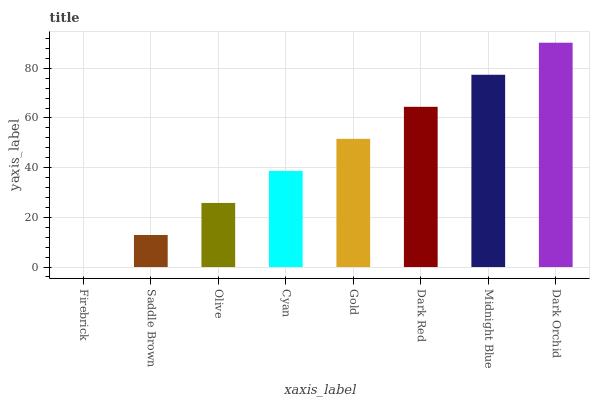Is Firebrick the minimum?
Answer yes or no. Yes. Is Dark Orchid the maximum?
Answer yes or no. Yes. Is Saddle Brown the minimum?
Answer yes or no. No. Is Saddle Brown the maximum?
Answer yes or no. No. Is Saddle Brown greater than Firebrick?
Answer yes or no. Yes. Is Firebrick less than Saddle Brown?
Answer yes or no. Yes. Is Firebrick greater than Saddle Brown?
Answer yes or no. No. Is Saddle Brown less than Firebrick?
Answer yes or no. No. Is Gold the high median?
Answer yes or no. Yes. Is Cyan the low median?
Answer yes or no. Yes. Is Dark Orchid the high median?
Answer yes or no. No. Is Firebrick the low median?
Answer yes or no. No. 